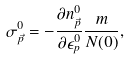<formula> <loc_0><loc_0><loc_500><loc_500>\sigma ^ { 0 } _ { \vec { p } } = - \frac { \partial n _ { \vec { p } } ^ { 0 } } { \partial \epsilon _ { p } ^ { 0 } } \frac { m } { N ( 0 ) } ,</formula> 